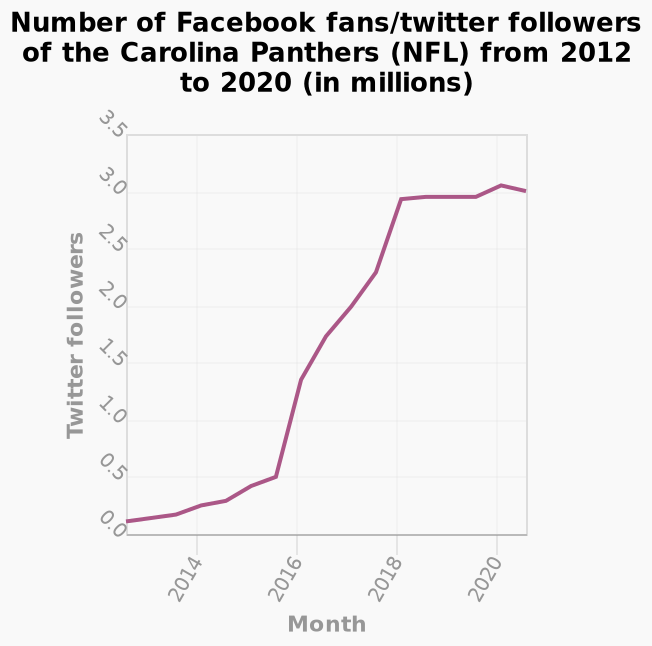<image>
What was the trend in the number of Twitter followers from 2012 to 2020?  The number of Twitter followers greatly increased in numbers. What is plotted along the y-axis of the line chart?  Twitter followers are plotted along the y-axis of the line chart. How many Twitter followers are there currently?  Currently, there are 3 million Twitter followers. 